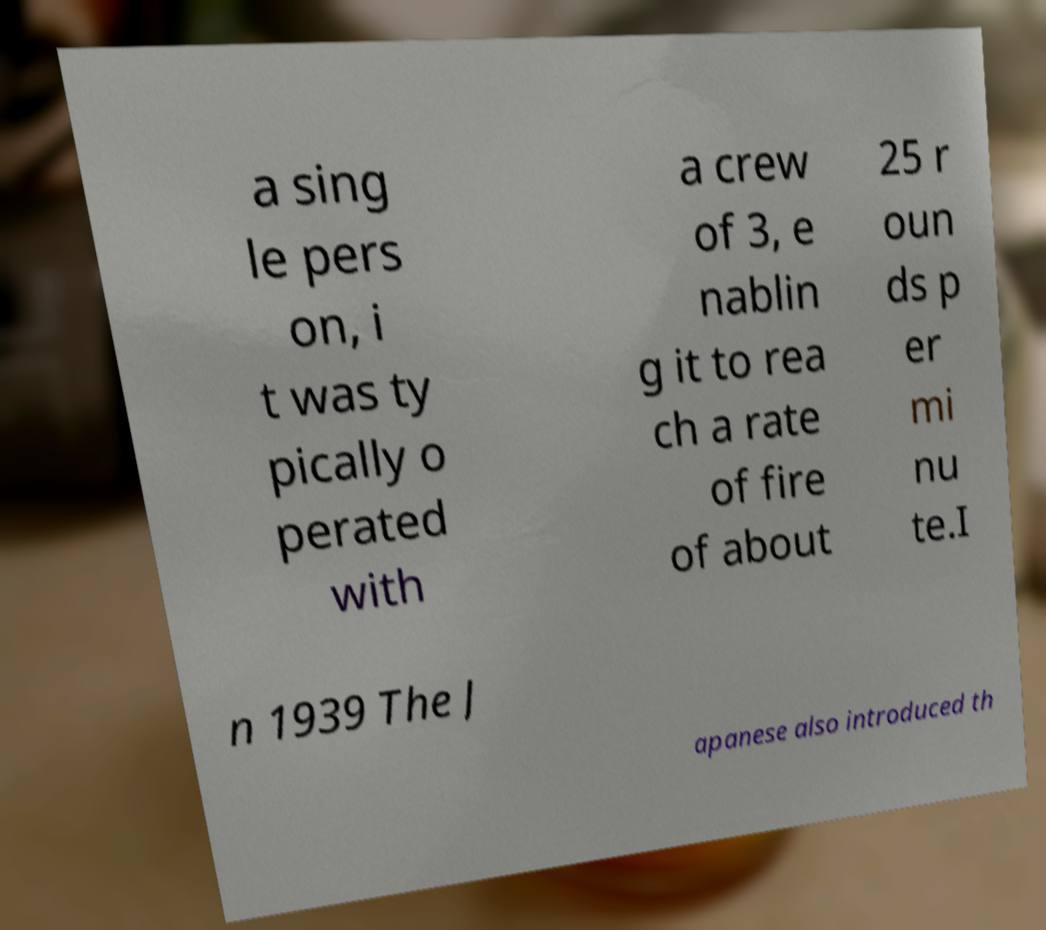For documentation purposes, I need the text within this image transcribed. Could you provide that? a sing le pers on, i t was ty pically o perated with a crew of 3, e nablin g it to rea ch a rate of fire of about 25 r oun ds p er mi nu te.I n 1939 The J apanese also introduced th 